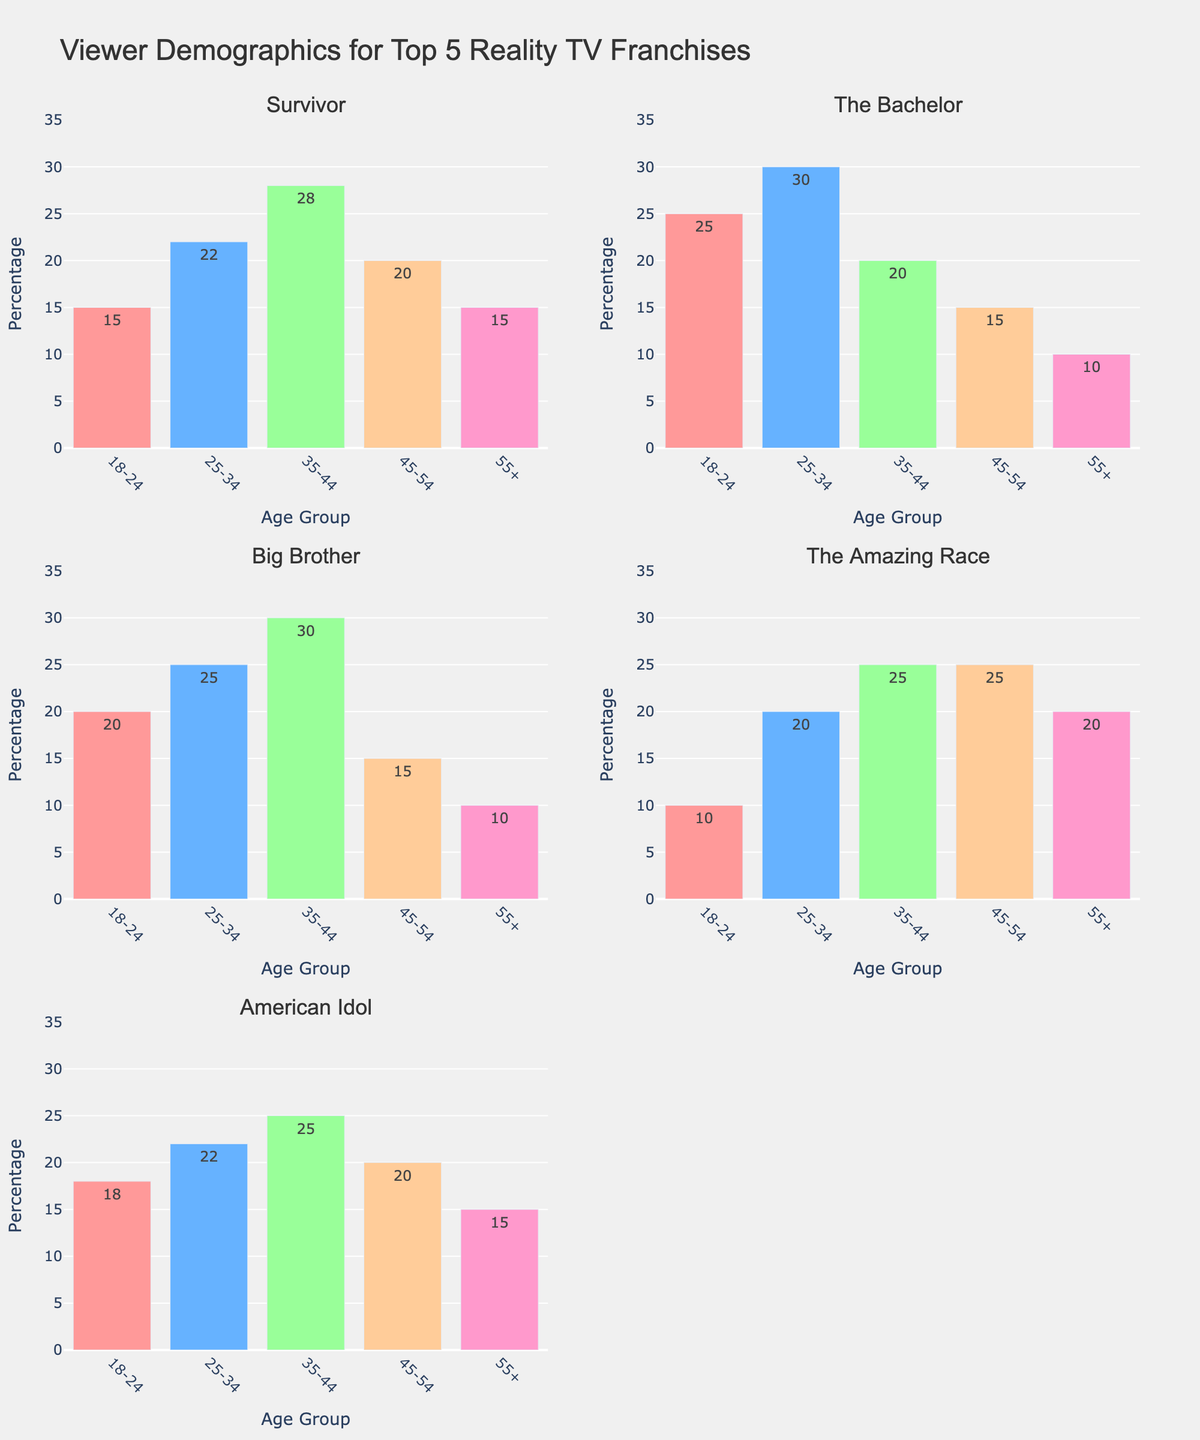what is the highest value for Survivor in any age group? To find the highest value for "Survivor," you look at the values for each age group: 18-24 (15%), 25-34 (22%), 35-44 (28%), 45-54 (20%), 55+ (15%). The highest percentage is 35-44 with 28%.
Answer: 28% What age group has the lowest viewer percentage in The Bachelor? For "The Bachelor," the percentage of viewers by age group is: 18-24 (25%), 25-34 (30%), 35-44 (20%), 45-54 (15%), 55+ (10%). The lowest percentage is in the 55+ age group with 10%.
Answer: 55+ Which franchise has the narrowest range between its highest and lowest viewer percentages? Calculating the range for each franchise:
- Survivor: highest (28%) - lowest (15%) = 13
- The Bachelor: highest (30%) - lowest (10%) = 20
- Big Brother: highest (30%) - lowest (10%) = 20
- The Amazing Race: highest (25%) - lowest (10%) = 15
- American Idol: highest (25%) - lowest (15%) = 10
The franchise with the narrowest range is "American Idol" at 10%.
Answer: American Idol What's the total percentage of viewers aged 18-34 for The Amazing Race? For "The Amazing Race," add the percentages for the 18-24 and 25-34 age groups: 10% + 20% = 30%.
Answer: 30% Which two age groups are equal in percentage for American Idol? For "American Idol," the percentages are: 18-24 (18%), 25-34 (22%), 35-44 (25%), 45-54 (20%), 55+ (15%). The percentages for the 45-54 and 55+ age groups are both 20%.
Answer: 45-54 and 55+ What's the average viewer percentage for the 35-44 age group across all franchises? Adding the percentages for each franchise's 35-44 age group: Survivor (28%) + The Bachelor (20%) + Big Brother (30%) + The Amazing Race (25%) + American Idol (25%) = 128%. Dividing by the 5 franchises: 128% / 5 = 25.6%.
Answer: 25.6% Which franchise has the most balanced distribution of viewers across all age groups? To determine the most balanced distribution, observe the visually closest percentages to each other:
- Survivor has a spread of 13%
- The Bachelor: 20%
- Big Brother: 20%
- The Amazing Race: 15%
- American Idol: 10%
"American Idol" is the most balanced with the narrowest range of 10%.
Answer: American Idol 